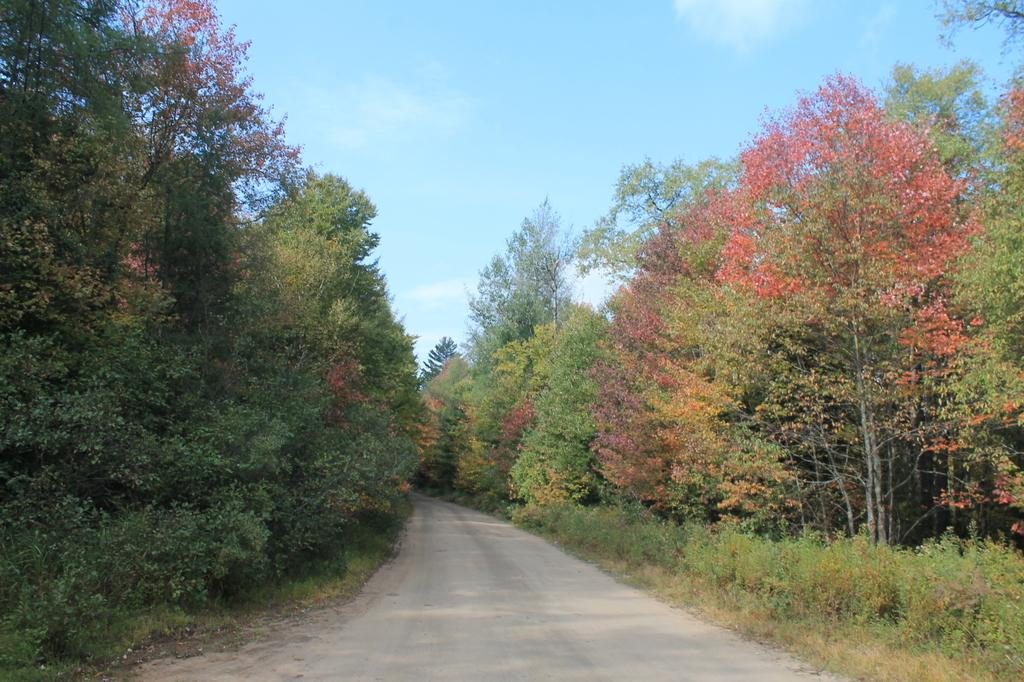What is the main feature of the image? There is a road in the picture. What can be seen on both sides of the road? There are plants and trees on both sides of the road. What is the condition of the sky in the image? The sky is clear in the picture. Where is the nearest zoo to the location shown in the image? There is no information about a zoo or its location in the image. What grade is the road in the image? The image does not provide information about the grade of the road. 